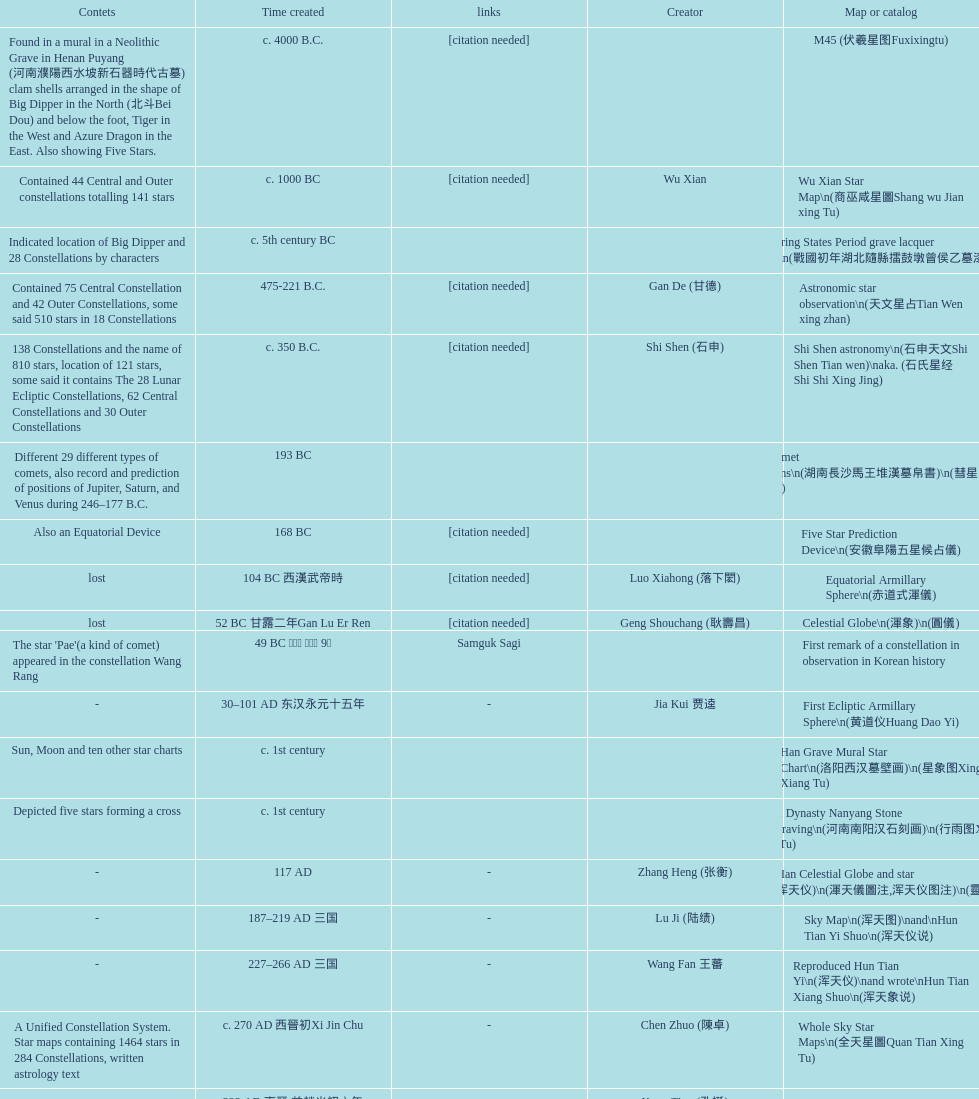Which was the first chinese star map known to have been created? M45 (伏羲星图Fuxixingtu). 